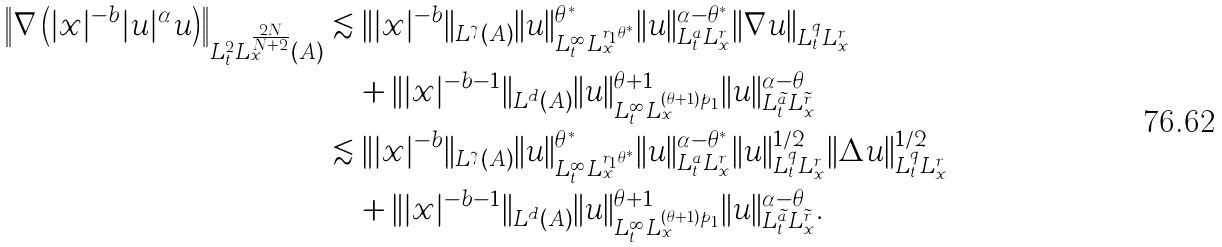Convert formula to latex. <formula><loc_0><loc_0><loc_500><loc_500>\left \| \nabla \left ( | x | ^ { - b } | u | ^ { \alpha } u \right ) \right \| _ { L _ { t } ^ { 2 } L _ { x } ^ { \frac { 2 N } { N + 2 } } ( A ) } & \lesssim \| | x | ^ { - b } \| _ { L ^ { \gamma } ( A ) } \| u \| _ { L ^ { \infty } _ { t } L _ { x } ^ { r _ { 1 } \theta ^ { * } } } ^ { \theta ^ { * } } \| u \| _ { L ^ { a } _ { t } L _ { x } ^ { r } } ^ { \alpha - \theta ^ { * } } \| \nabla u \| _ { L ^ { q } _ { t } L ^ { r } _ { x } } \\ & \quad + \| | x | ^ { - b - 1 } \| _ { L ^ { d } ( A ) } \| u \| _ { L ^ { \infty } _ { t } L _ { x } ^ { ( \theta + 1 ) p _ { 1 } } } ^ { \theta + 1 } \| u \| _ { L _ { t } ^ { \widetilde { a } } L _ { x } ^ { \widetilde { r } } } ^ { \alpha - \theta } \\ & \lesssim \| | x | ^ { - b } \| _ { L ^ { \gamma } ( A ) } \| u \| _ { L ^ { \infty } _ { t } L _ { x } ^ { r _ { 1 } \theta ^ { * } } } ^ { \theta ^ { * } } \| u \| _ { L ^ { a } _ { t } L _ { x } ^ { r } } ^ { \alpha - \theta ^ { * } } \| u \| _ { L ^ { q } _ { t } L ^ { r } _ { x } } ^ { 1 / 2 } \| \Delta u \| _ { L ^ { q } _ { t } L ^ { r } _ { x } } ^ { 1 / 2 } \\ & \quad + \| | x | ^ { - b - 1 } \| _ { L ^ { d } ( A ) } \| u \| _ { L ^ { \infty } _ { t } L _ { x } ^ { ( \theta + 1 ) p _ { 1 } } } ^ { \theta + 1 } \| u \| _ { L _ { t } ^ { \widetilde { a } } L _ { x } ^ { \widetilde { r } } } ^ { \alpha - \theta } .</formula> 